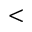Convert formula to latex. <formula><loc_0><loc_0><loc_500><loc_500><</formula> 